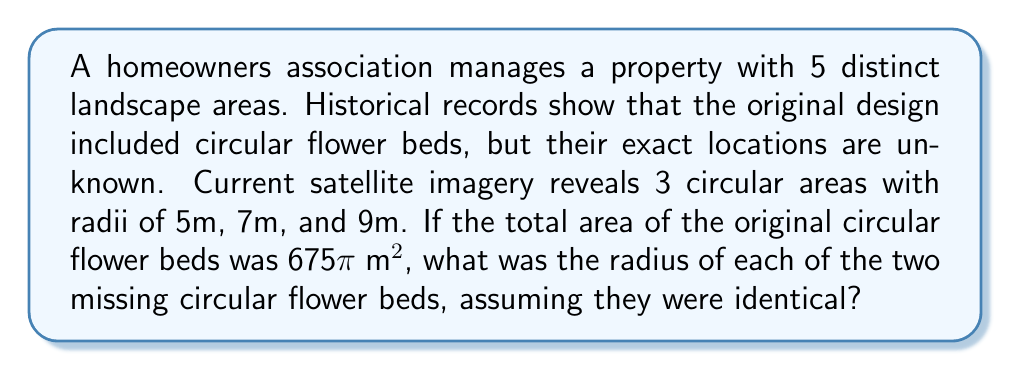Give your solution to this math problem. Let's approach this step-by-step:

1) First, let's calculate the total area of the known circular flower beds:
   Area = $\pi r^2$
   
   For r = 5m: $A_1 = \pi (5^2) = 25\pi$ m²
   For r = 7m: $A_2 = \pi (7^2) = 49\pi$ m²
   For r = 9m: $A_3 = \pi (9^2) = 81\pi$ m²

2) Total area of known flower beds:
   $A_{known} = 25\pi + 49\pi + 81\pi = 155\pi$ m²

3) The total area of all flower beds is given as 675π m². So, the area of the two missing flower beds is:
   $A_{missing} = 675\pi - 155\pi = 520\pi$ m²

4) Since the two missing flower beds are identical, each one has an area of:
   $A_{each} = 520\pi / 2 = 260\pi$ m²

5) Now, we can find the radius of each missing flower bed:
   $260\pi = \pi r^2$
   $260 = r^2$
   $r = \sqrt{260} \approx 16.12$ m

Therefore, the radius of each of the two missing circular flower beds is approximately 16.12 meters.
Answer: $\sqrt{260}$ m (≈ 16.12 m) 